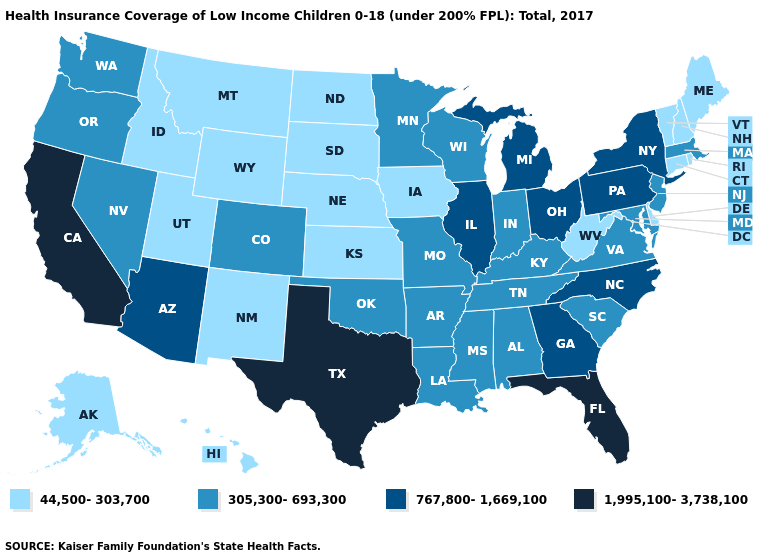How many symbols are there in the legend?
Keep it brief. 4. Among the states that border Oregon , which have the highest value?
Give a very brief answer. California. What is the value of South Carolina?
Quick response, please. 305,300-693,300. What is the value of North Carolina?
Concise answer only. 767,800-1,669,100. What is the value of Rhode Island?
Answer briefly. 44,500-303,700. Name the states that have a value in the range 1,995,100-3,738,100?
Answer briefly. California, Florida, Texas. Which states have the lowest value in the Northeast?
Concise answer only. Connecticut, Maine, New Hampshire, Rhode Island, Vermont. Name the states that have a value in the range 767,800-1,669,100?
Be succinct. Arizona, Georgia, Illinois, Michigan, New York, North Carolina, Ohio, Pennsylvania. What is the value of Mississippi?
Answer briefly. 305,300-693,300. What is the value of Colorado?
Give a very brief answer. 305,300-693,300. Among the states that border Arizona , does California have the highest value?
Quick response, please. Yes. Which states have the highest value in the USA?
Write a very short answer. California, Florida, Texas. Does Illinois have the lowest value in the USA?
Quick response, please. No. 